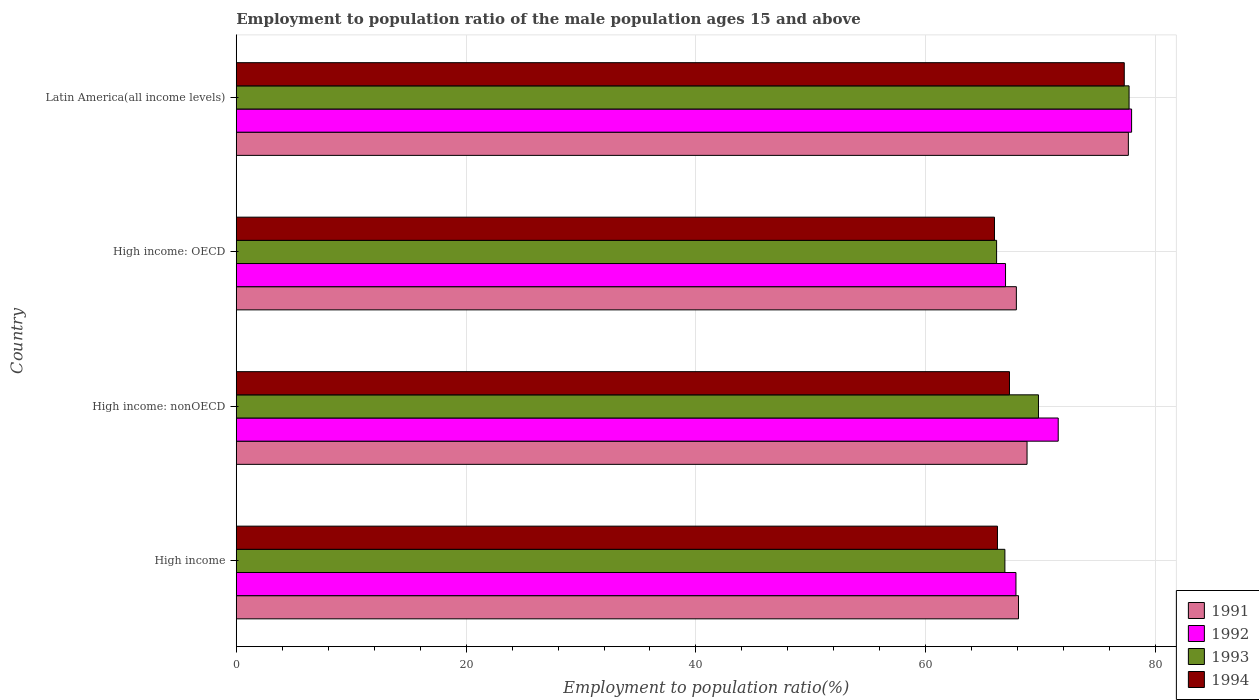How many groups of bars are there?
Your answer should be very brief. 4. Are the number of bars per tick equal to the number of legend labels?
Give a very brief answer. Yes. Are the number of bars on each tick of the Y-axis equal?
Give a very brief answer. Yes. How many bars are there on the 2nd tick from the top?
Provide a short and direct response. 4. How many bars are there on the 3rd tick from the bottom?
Keep it short and to the point. 4. What is the label of the 1st group of bars from the top?
Keep it short and to the point. Latin America(all income levels). In how many cases, is the number of bars for a given country not equal to the number of legend labels?
Your answer should be compact. 0. What is the employment to population ratio in 1992 in High income?
Ensure brevity in your answer.  67.85. Across all countries, what is the maximum employment to population ratio in 1993?
Keep it short and to the point. 77.69. Across all countries, what is the minimum employment to population ratio in 1994?
Ensure brevity in your answer.  65.98. In which country was the employment to population ratio in 1994 maximum?
Provide a short and direct response. Latin America(all income levels). In which country was the employment to population ratio in 1992 minimum?
Provide a succinct answer. High income: OECD. What is the total employment to population ratio in 1993 in the graph?
Your answer should be compact. 280.54. What is the difference between the employment to population ratio in 1994 in High income: OECD and that in Latin America(all income levels)?
Keep it short and to the point. -11.29. What is the difference between the employment to population ratio in 1994 in Latin America(all income levels) and the employment to population ratio in 1992 in High income: nonOECD?
Your response must be concise. 5.75. What is the average employment to population ratio in 1994 per country?
Your answer should be very brief. 69.19. What is the difference between the employment to population ratio in 1993 and employment to population ratio in 1994 in Latin America(all income levels)?
Give a very brief answer. 0.42. In how many countries, is the employment to population ratio in 1992 greater than 72 %?
Make the answer very short. 1. What is the ratio of the employment to population ratio in 1991 in High income to that in High income: OECD?
Keep it short and to the point. 1. Is the employment to population ratio in 1993 in High income: OECD less than that in Latin America(all income levels)?
Keep it short and to the point. Yes. Is the difference between the employment to population ratio in 1993 in High income: OECD and High income: nonOECD greater than the difference between the employment to population ratio in 1994 in High income: OECD and High income: nonOECD?
Ensure brevity in your answer.  No. What is the difference between the highest and the second highest employment to population ratio in 1992?
Ensure brevity in your answer.  6.38. What is the difference between the highest and the lowest employment to population ratio in 1992?
Offer a terse response. 10.97. In how many countries, is the employment to population ratio in 1992 greater than the average employment to population ratio in 1992 taken over all countries?
Provide a short and direct response. 2. Is the sum of the employment to population ratio in 1994 in High income: OECD and Latin America(all income levels) greater than the maximum employment to population ratio in 1992 across all countries?
Provide a short and direct response. Yes. Is it the case that in every country, the sum of the employment to population ratio in 1992 and employment to population ratio in 1993 is greater than the employment to population ratio in 1991?
Offer a very short reply. Yes. How many bars are there?
Provide a short and direct response. 16. How many countries are there in the graph?
Offer a terse response. 4. Are the values on the major ticks of X-axis written in scientific E-notation?
Provide a succinct answer. No. Where does the legend appear in the graph?
Your answer should be compact. Bottom right. How many legend labels are there?
Provide a short and direct response. 4. What is the title of the graph?
Your answer should be compact. Employment to population ratio of the male population ages 15 and above. Does "2001" appear as one of the legend labels in the graph?
Your answer should be compact. No. What is the label or title of the X-axis?
Offer a terse response. Employment to population ratio(%). What is the Employment to population ratio(%) of 1991 in High income?
Your response must be concise. 68.07. What is the Employment to population ratio(%) of 1992 in High income?
Offer a terse response. 67.85. What is the Employment to population ratio(%) in 1993 in High income?
Keep it short and to the point. 66.88. What is the Employment to population ratio(%) in 1994 in High income?
Your response must be concise. 66.24. What is the Employment to population ratio(%) of 1991 in High income: nonOECD?
Ensure brevity in your answer.  68.81. What is the Employment to population ratio(%) of 1992 in High income: nonOECD?
Keep it short and to the point. 71.53. What is the Employment to population ratio(%) of 1993 in High income: nonOECD?
Ensure brevity in your answer.  69.81. What is the Employment to population ratio(%) of 1994 in High income: nonOECD?
Give a very brief answer. 67.28. What is the Employment to population ratio(%) of 1991 in High income: OECD?
Keep it short and to the point. 67.88. What is the Employment to population ratio(%) of 1992 in High income: OECD?
Make the answer very short. 66.94. What is the Employment to population ratio(%) of 1993 in High income: OECD?
Make the answer very short. 66.16. What is the Employment to population ratio(%) in 1994 in High income: OECD?
Provide a succinct answer. 65.98. What is the Employment to population ratio(%) of 1991 in Latin America(all income levels)?
Make the answer very short. 77.63. What is the Employment to population ratio(%) of 1992 in Latin America(all income levels)?
Offer a very short reply. 77.91. What is the Employment to population ratio(%) in 1993 in Latin America(all income levels)?
Make the answer very short. 77.69. What is the Employment to population ratio(%) of 1994 in Latin America(all income levels)?
Keep it short and to the point. 77.27. Across all countries, what is the maximum Employment to population ratio(%) of 1991?
Your answer should be very brief. 77.63. Across all countries, what is the maximum Employment to population ratio(%) in 1992?
Offer a terse response. 77.91. Across all countries, what is the maximum Employment to population ratio(%) of 1993?
Provide a succinct answer. 77.69. Across all countries, what is the maximum Employment to population ratio(%) in 1994?
Provide a succinct answer. 77.27. Across all countries, what is the minimum Employment to population ratio(%) in 1991?
Provide a short and direct response. 67.88. Across all countries, what is the minimum Employment to population ratio(%) of 1992?
Keep it short and to the point. 66.94. Across all countries, what is the minimum Employment to population ratio(%) of 1993?
Your answer should be compact. 66.16. Across all countries, what is the minimum Employment to population ratio(%) of 1994?
Your response must be concise. 65.98. What is the total Employment to population ratio(%) of 1991 in the graph?
Ensure brevity in your answer.  282.39. What is the total Employment to population ratio(%) of 1992 in the graph?
Provide a short and direct response. 284.22. What is the total Employment to population ratio(%) of 1993 in the graph?
Give a very brief answer. 280.54. What is the total Employment to population ratio(%) of 1994 in the graph?
Your answer should be very brief. 276.77. What is the difference between the Employment to population ratio(%) in 1991 in High income and that in High income: nonOECD?
Your answer should be very brief. -0.74. What is the difference between the Employment to population ratio(%) of 1992 in High income and that in High income: nonOECD?
Make the answer very short. -3.68. What is the difference between the Employment to population ratio(%) in 1993 in High income and that in High income: nonOECD?
Keep it short and to the point. -2.92. What is the difference between the Employment to population ratio(%) in 1994 in High income and that in High income: nonOECD?
Your answer should be compact. -1.05. What is the difference between the Employment to population ratio(%) of 1991 in High income and that in High income: OECD?
Your response must be concise. 0.18. What is the difference between the Employment to population ratio(%) of 1992 in High income and that in High income: OECD?
Offer a terse response. 0.91. What is the difference between the Employment to population ratio(%) in 1993 in High income and that in High income: OECD?
Ensure brevity in your answer.  0.72. What is the difference between the Employment to population ratio(%) of 1994 in High income and that in High income: OECD?
Offer a very short reply. 0.26. What is the difference between the Employment to population ratio(%) of 1991 in High income and that in Latin America(all income levels)?
Offer a very short reply. -9.56. What is the difference between the Employment to population ratio(%) of 1992 in High income and that in Latin America(all income levels)?
Offer a terse response. -10.06. What is the difference between the Employment to population ratio(%) in 1993 in High income and that in Latin America(all income levels)?
Offer a terse response. -10.81. What is the difference between the Employment to population ratio(%) of 1994 in High income and that in Latin America(all income levels)?
Your response must be concise. -11.03. What is the difference between the Employment to population ratio(%) of 1991 in High income: nonOECD and that in High income: OECD?
Ensure brevity in your answer.  0.93. What is the difference between the Employment to population ratio(%) in 1992 in High income: nonOECD and that in High income: OECD?
Offer a very short reply. 4.58. What is the difference between the Employment to population ratio(%) of 1993 in High income: nonOECD and that in High income: OECD?
Offer a very short reply. 3.64. What is the difference between the Employment to population ratio(%) of 1994 in High income: nonOECD and that in High income: OECD?
Offer a very short reply. 1.31. What is the difference between the Employment to population ratio(%) of 1991 in High income: nonOECD and that in Latin America(all income levels)?
Ensure brevity in your answer.  -8.82. What is the difference between the Employment to population ratio(%) in 1992 in High income: nonOECD and that in Latin America(all income levels)?
Give a very brief answer. -6.38. What is the difference between the Employment to population ratio(%) of 1993 in High income: nonOECD and that in Latin America(all income levels)?
Offer a terse response. -7.88. What is the difference between the Employment to population ratio(%) of 1994 in High income: nonOECD and that in Latin America(all income levels)?
Your answer should be compact. -9.99. What is the difference between the Employment to population ratio(%) of 1991 in High income: OECD and that in Latin America(all income levels)?
Provide a succinct answer. -9.75. What is the difference between the Employment to population ratio(%) in 1992 in High income: OECD and that in Latin America(all income levels)?
Offer a very short reply. -10.97. What is the difference between the Employment to population ratio(%) in 1993 in High income: OECD and that in Latin America(all income levels)?
Offer a terse response. -11.53. What is the difference between the Employment to population ratio(%) in 1994 in High income: OECD and that in Latin America(all income levels)?
Give a very brief answer. -11.29. What is the difference between the Employment to population ratio(%) of 1991 in High income and the Employment to population ratio(%) of 1992 in High income: nonOECD?
Give a very brief answer. -3.46. What is the difference between the Employment to population ratio(%) in 1991 in High income and the Employment to population ratio(%) in 1993 in High income: nonOECD?
Provide a succinct answer. -1.74. What is the difference between the Employment to population ratio(%) in 1991 in High income and the Employment to population ratio(%) in 1994 in High income: nonOECD?
Give a very brief answer. 0.78. What is the difference between the Employment to population ratio(%) of 1992 in High income and the Employment to population ratio(%) of 1993 in High income: nonOECD?
Your response must be concise. -1.96. What is the difference between the Employment to population ratio(%) of 1992 in High income and the Employment to population ratio(%) of 1994 in High income: nonOECD?
Keep it short and to the point. 0.56. What is the difference between the Employment to population ratio(%) in 1993 in High income and the Employment to population ratio(%) in 1994 in High income: nonOECD?
Ensure brevity in your answer.  -0.4. What is the difference between the Employment to population ratio(%) in 1991 in High income and the Employment to population ratio(%) in 1992 in High income: OECD?
Your response must be concise. 1.13. What is the difference between the Employment to population ratio(%) in 1991 in High income and the Employment to population ratio(%) in 1993 in High income: OECD?
Provide a short and direct response. 1.91. What is the difference between the Employment to population ratio(%) of 1991 in High income and the Employment to population ratio(%) of 1994 in High income: OECD?
Offer a terse response. 2.09. What is the difference between the Employment to population ratio(%) in 1992 in High income and the Employment to population ratio(%) in 1993 in High income: OECD?
Ensure brevity in your answer.  1.69. What is the difference between the Employment to population ratio(%) of 1992 in High income and the Employment to population ratio(%) of 1994 in High income: OECD?
Make the answer very short. 1.87. What is the difference between the Employment to population ratio(%) of 1993 in High income and the Employment to population ratio(%) of 1994 in High income: OECD?
Provide a succinct answer. 0.91. What is the difference between the Employment to population ratio(%) in 1991 in High income and the Employment to population ratio(%) in 1992 in Latin America(all income levels)?
Ensure brevity in your answer.  -9.84. What is the difference between the Employment to population ratio(%) in 1991 in High income and the Employment to population ratio(%) in 1993 in Latin America(all income levels)?
Your answer should be very brief. -9.62. What is the difference between the Employment to population ratio(%) in 1991 in High income and the Employment to population ratio(%) in 1994 in Latin America(all income levels)?
Your answer should be compact. -9.2. What is the difference between the Employment to population ratio(%) of 1992 in High income and the Employment to population ratio(%) of 1993 in Latin America(all income levels)?
Your response must be concise. -9.84. What is the difference between the Employment to population ratio(%) in 1992 in High income and the Employment to population ratio(%) in 1994 in Latin America(all income levels)?
Ensure brevity in your answer.  -9.42. What is the difference between the Employment to population ratio(%) in 1993 in High income and the Employment to population ratio(%) in 1994 in Latin America(all income levels)?
Your answer should be compact. -10.39. What is the difference between the Employment to population ratio(%) of 1991 in High income: nonOECD and the Employment to population ratio(%) of 1992 in High income: OECD?
Your answer should be very brief. 1.87. What is the difference between the Employment to population ratio(%) of 1991 in High income: nonOECD and the Employment to population ratio(%) of 1993 in High income: OECD?
Offer a very short reply. 2.65. What is the difference between the Employment to population ratio(%) in 1991 in High income: nonOECD and the Employment to population ratio(%) in 1994 in High income: OECD?
Ensure brevity in your answer.  2.83. What is the difference between the Employment to population ratio(%) in 1992 in High income: nonOECD and the Employment to population ratio(%) in 1993 in High income: OECD?
Give a very brief answer. 5.36. What is the difference between the Employment to population ratio(%) of 1992 in High income: nonOECD and the Employment to population ratio(%) of 1994 in High income: OECD?
Offer a terse response. 5.55. What is the difference between the Employment to population ratio(%) of 1993 in High income: nonOECD and the Employment to population ratio(%) of 1994 in High income: OECD?
Ensure brevity in your answer.  3.83. What is the difference between the Employment to population ratio(%) in 1991 in High income: nonOECD and the Employment to population ratio(%) in 1992 in Latin America(all income levels)?
Your answer should be compact. -9.1. What is the difference between the Employment to population ratio(%) in 1991 in High income: nonOECD and the Employment to population ratio(%) in 1993 in Latin America(all income levels)?
Your answer should be compact. -8.88. What is the difference between the Employment to population ratio(%) in 1991 in High income: nonOECD and the Employment to population ratio(%) in 1994 in Latin America(all income levels)?
Provide a short and direct response. -8.46. What is the difference between the Employment to population ratio(%) in 1992 in High income: nonOECD and the Employment to population ratio(%) in 1993 in Latin America(all income levels)?
Ensure brevity in your answer.  -6.17. What is the difference between the Employment to population ratio(%) of 1992 in High income: nonOECD and the Employment to population ratio(%) of 1994 in Latin America(all income levels)?
Give a very brief answer. -5.75. What is the difference between the Employment to population ratio(%) in 1993 in High income: nonOECD and the Employment to population ratio(%) in 1994 in Latin America(all income levels)?
Ensure brevity in your answer.  -7.47. What is the difference between the Employment to population ratio(%) of 1991 in High income: OECD and the Employment to population ratio(%) of 1992 in Latin America(all income levels)?
Your answer should be compact. -10.03. What is the difference between the Employment to population ratio(%) in 1991 in High income: OECD and the Employment to population ratio(%) in 1993 in Latin America(all income levels)?
Offer a very short reply. -9.81. What is the difference between the Employment to population ratio(%) of 1991 in High income: OECD and the Employment to population ratio(%) of 1994 in Latin America(all income levels)?
Provide a short and direct response. -9.39. What is the difference between the Employment to population ratio(%) in 1992 in High income: OECD and the Employment to population ratio(%) in 1993 in Latin America(all income levels)?
Provide a succinct answer. -10.75. What is the difference between the Employment to population ratio(%) of 1992 in High income: OECD and the Employment to population ratio(%) of 1994 in Latin America(all income levels)?
Your response must be concise. -10.33. What is the difference between the Employment to population ratio(%) of 1993 in High income: OECD and the Employment to population ratio(%) of 1994 in Latin America(all income levels)?
Your answer should be very brief. -11.11. What is the average Employment to population ratio(%) in 1991 per country?
Provide a succinct answer. 70.6. What is the average Employment to population ratio(%) in 1992 per country?
Your answer should be very brief. 71.06. What is the average Employment to population ratio(%) of 1993 per country?
Provide a short and direct response. 70.14. What is the average Employment to population ratio(%) of 1994 per country?
Ensure brevity in your answer.  69.19. What is the difference between the Employment to population ratio(%) of 1991 and Employment to population ratio(%) of 1992 in High income?
Give a very brief answer. 0.22. What is the difference between the Employment to population ratio(%) of 1991 and Employment to population ratio(%) of 1993 in High income?
Give a very brief answer. 1.18. What is the difference between the Employment to population ratio(%) of 1991 and Employment to population ratio(%) of 1994 in High income?
Make the answer very short. 1.83. What is the difference between the Employment to population ratio(%) of 1992 and Employment to population ratio(%) of 1994 in High income?
Offer a terse response. 1.61. What is the difference between the Employment to population ratio(%) in 1993 and Employment to population ratio(%) in 1994 in High income?
Give a very brief answer. 0.65. What is the difference between the Employment to population ratio(%) of 1991 and Employment to population ratio(%) of 1992 in High income: nonOECD?
Give a very brief answer. -2.71. What is the difference between the Employment to population ratio(%) of 1991 and Employment to population ratio(%) of 1993 in High income: nonOECD?
Your answer should be compact. -0.99. What is the difference between the Employment to population ratio(%) in 1991 and Employment to population ratio(%) in 1994 in High income: nonOECD?
Keep it short and to the point. 1.53. What is the difference between the Employment to population ratio(%) of 1992 and Employment to population ratio(%) of 1993 in High income: nonOECD?
Provide a short and direct response. 1.72. What is the difference between the Employment to population ratio(%) of 1992 and Employment to population ratio(%) of 1994 in High income: nonOECD?
Offer a terse response. 4.24. What is the difference between the Employment to population ratio(%) of 1993 and Employment to population ratio(%) of 1994 in High income: nonOECD?
Offer a very short reply. 2.52. What is the difference between the Employment to population ratio(%) of 1991 and Employment to population ratio(%) of 1992 in High income: OECD?
Your answer should be compact. 0.94. What is the difference between the Employment to population ratio(%) of 1991 and Employment to population ratio(%) of 1993 in High income: OECD?
Provide a succinct answer. 1.72. What is the difference between the Employment to population ratio(%) of 1991 and Employment to population ratio(%) of 1994 in High income: OECD?
Provide a succinct answer. 1.9. What is the difference between the Employment to population ratio(%) of 1992 and Employment to population ratio(%) of 1993 in High income: OECD?
Give a very brief answer. 0.78. What is the difference between the Employment to population ratio(%) of 1992 and Employment to population ratio(%) of 1994 in High income: OECD?
Provide a short and direct response. 0.96. What is the difference between the Employment to population ratio(%) of 1993 and Employment to population ratio(%) of 1994 in High income: OECD?
Provide a short and direct response. 0.18. What is the difference between the Employment to population ratio(%) of 1991 and Employment to population ratio(%) of 1992 in Latin America(all income levels)?
Provide a succinct answer. -0.28. What is the difference between the Employment to population ratio(%) of 1991 and Employment to population ratio(%) of 1993 in Latin America(all income levels)?
Ensure brevity in your answer.  -0.06. What is the difference between the Employment to population ratio(%) of 1991 and Employment to population ratio(%) of 1994 in Latin America(all income levels)?
Offer a very short reply. 0.36. What is the difference between the Employment to population ratio(%) in 1992 and Employment to population ratio(%) in 1993 in Latin America(all income levels)?
Offer a terse response. 0.22. What is the difference between the Employment to population ratio(%) of 1992 and Employment to population ratio(%) of 1994 in Latin America(all income levels)?
Provide a succinct answer. 0.64. What is the difference between the Employment to population ratio(%) in 1993 and Employment to population ratio(%) in 1994 in Latin America(all income levels)?
Give a very brief answer. 0.42. What is the ratio of the Employment to population ratio(%) in 1992 in High income to that in High income: nonOECD?
Your response must be concise. 0.95. What is the ratio of the Employment to population ratio(%) of 1993 in High income to that in High income: nonOECD?
Offer a terse response. 0.96. What is the ratio of the Employment to population ratio(%) of 1994 in High income to that in High income: nonOECD?
Your answer should be very brief. 0.98. What is the ratio of the Employment to population ratio(%) in 1991 in High income to that in High income: OECD?
Provide a short and direct response. 1. What is the ratio of the Employment to population ratio(%) of 1992 in High income to that in High income: OECD?
Ensure brevity in your answer.  1.01. What is the ratio of the Employment to population ratio(%) of 1993 in High income to that in High income: OECD?
Provide a succinct answer. 1.01. What is the ratio of the Employment to population ratio(%) in 1994 in High income to that in High income: OECD?
Your answer should be compact. 1. What is the ratio of the Employment to population ratio(%) of 1991 in High income to that in Latin America(all income levels)?
Give a very brief answer. 0.88. What is the ratio of the Employment to population ratio(%) of 1992 in High income to that in Latin America(all income levels)?
Offer a terse response. 0.87. What is the ratio of the Employment to population ratio(%) in 1993 in High income to that in Latin America(all income levels)?
Your answer should be very brief. 0.86. What is the ratio of the Employment to population ratio(%) in 1994 in High income to that in Latin America(all income levels)?
Make the answer very short. 0.86. What is the ratio of the Employment to population ratio(%) of 1991 in High income: nonOECD to that in High income: OECD?
Ensure brevity in your answer.  1.01. What is the ratio of the Employment to population ratio(%) in 1992 in High income: nonOECD to that in High income: OECD?
Ensure brevity in your answer.  1.07. What is the ratio of the Employment to population ratio(%) in 1993 in High income: nonOECD to that in High income: OECD?
Offer a terse response. 1.06. What is the ratio of the Employment to population ratio(%) of 1994 in High income: nonOECD to that in High income: OECD?
Your response must be concise. 1.02. What is the ratio of the Employment to population ratio(%) in 1991 in High income: nonOECD to that in Latin America(all income levels)?
Give a very brief answer. 0.89. What is the ratio of the Employment to population ratio(%) in 1992 in High income: nonOECD to that in Latin America(all income levels)?
Provide a succinct answer. 0.92. What is the ratio of the Employment to population ratio(%) in 1993 in High income: nonOECD to that in Latin America(all income levels)?
Make the answer very short. 0.9. What is the ratio of the Employment to population ratio(%) of 1994 in High income: nonOECD to that in Latin America(all income levels)?
Give a very brief answer. 0.87. What is the ratio of the Employment to population ratio(%) of 1991 in High income: OECD to that in Latin America(all income levels)?
Ensure brevity in your answer.  0.87. What is the ratio of the Employment to population ratio(%) in 1992 in High income: OECD to that in Latin America(all income levels)?
Your response must be concise. 0.86. What is the ratio of the Employment to population ratio(%) in 1993 in High income: OECD to that in Latin America(all income levels)?
Make the answer very short. 0.85. What is the ratio of the Employment to population ratio(%) in 1994 in High income: OECD to that in Latin America(all income levels)?
Your response must be concise. 0.85. What is the difference between the highest and the second highest Employment to population ratio(%) of 1991?
Provide a short and direct response. 8.82. What is the difference between the highest and the second highest Employment to population ratio(%) in 1992?
Make the answer very short. 6.38. What is the difference between the highest and the second highest Employment to population ratio(%) in 1993?
Make the answer very short. 7.88. What is the difference between the highest and the second highest Employment to population ratio(%) in 1994?
Provide a short and direct response. 9.99. What is the difference between the highest and the lowest Employment to population ratio(%) in 1991?
Give a very brief answer. 9.75. What is the difference between the highest and the lowest Employment to population ratio(%) of 1992?
Offer a terse response. 10.97. What is the difference between the highest and the lowest Employment to population ratio(%) in 1993?
Offer a terse response. 11.53. What is the difference between the highest and the lowest Employment to population ratio(%) in 1994?
Make the answer very short. 11.29. 